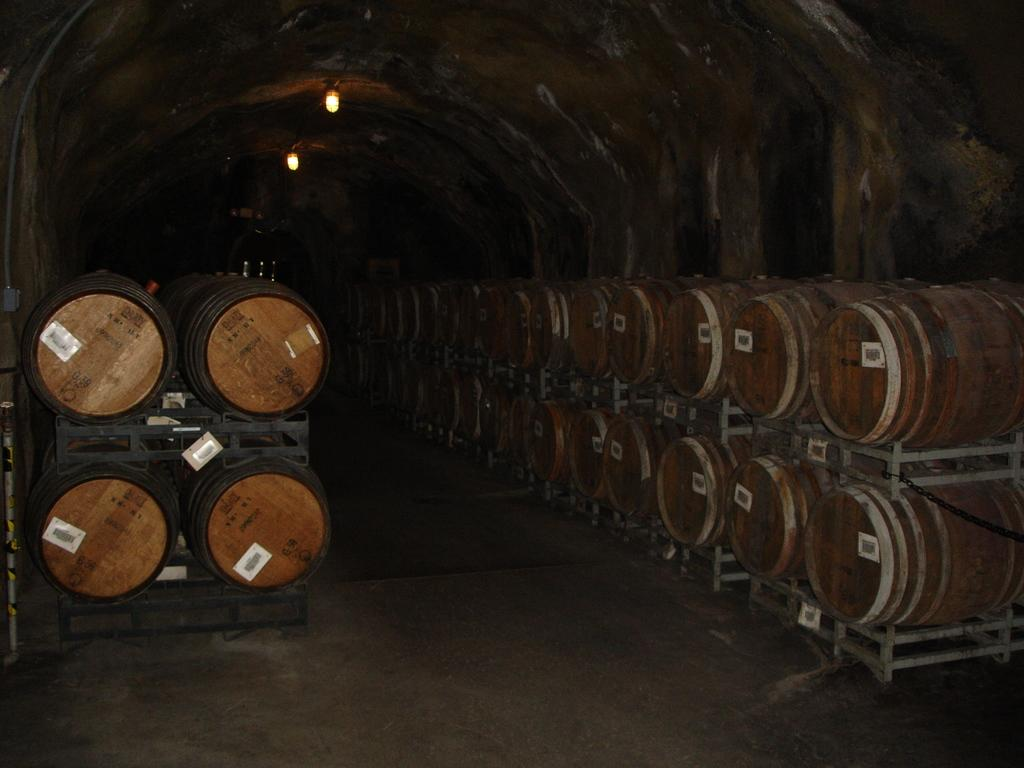What type of transportation is depicted in the image? There is a subway in the image. What can be found inside the subway? A lot of goods are kept inside the subway. How is the subway illuminated? There are two lights fixed to the roof of the subway. How does the crowd affect the movement of the subway in the image? There is no crowd present in the image, so it cannot affect the movement of the subway. 